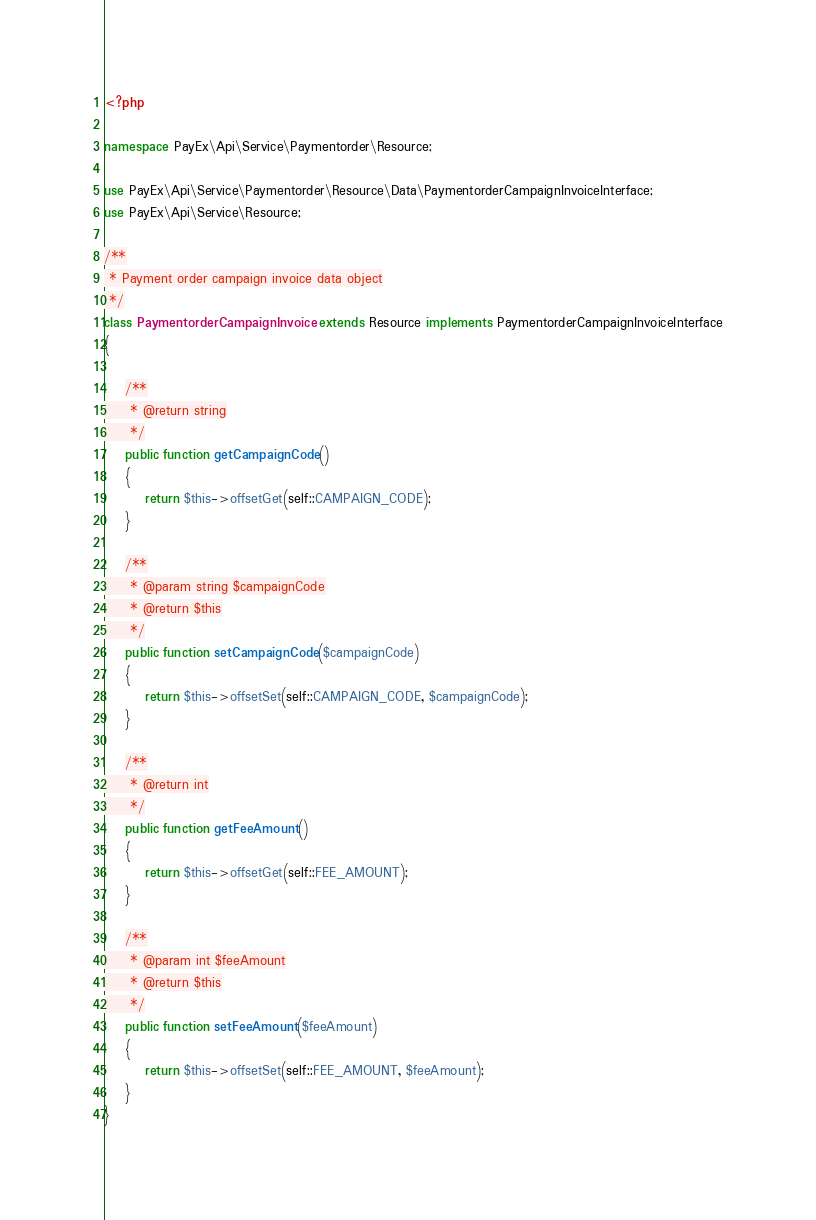<code> <loc_0><loc_0><loc_500><loc_500><_PHP_><?php

namespace PayEx\Api\Service\Paymentorder\Resource;

use PayEx\Api\Service\Paymentorder\Resource\Data\PaymentorderCampaignInvoiceInterface;
use PayEx\Api\Service\Resource;

/**
 * Payment order campaign invoice data object
 */
class PaymentorderCampaignInvoice extends Resource implements PaymentorderCampaignInvoiceInterface
{

    /**
     * @return string
     */
    public function getCampaignCode()
    {
        return $this->offsetGet(self::CAMPAIGN_CODE);
    }

    /**
     * @param string $campaignCode
     * @return $this
     */
    public function setCampaignCode($campaignCode)
    {
        return $this->offsetSet(self::CAMPAIGN_CODE, $campaignCode);
    }

    /**
     * @return int
     */
    public function getFeeAmount()
    {
        return $this->offsetGet(self::FEE_AMOUNT);
    }

    /**
     * @param int $feeAmount
     * @return $this
     */
    public function setFeeAmount($feeAmount)
    {
        return $this->offsetSet(self::FEE_AMOUNT, $feeAmount);
    }
}
</code> 